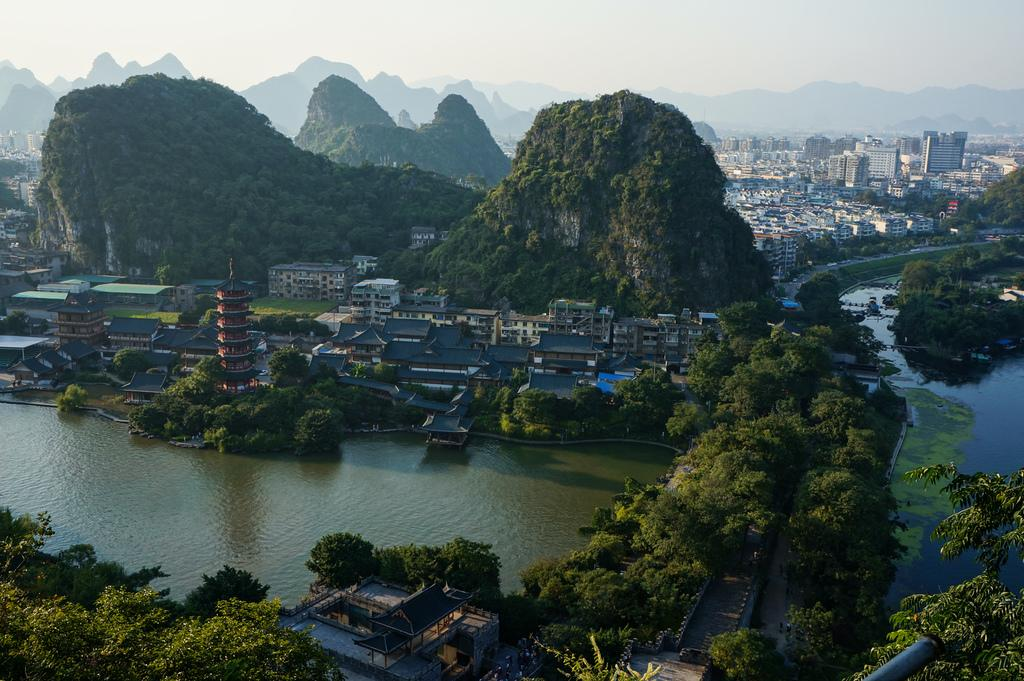What type of structures can be seen in the image? There are buildings in the image. What natural elements are present in the image? There are trees, hills, water, and grass in the image. What man-made feature is visible in the image? There is a road in the image. What part of the natural environment is visible in the image? The sky is visible in the image. Where is the creator of the image located? The creator of the image is not present in the image. What type of sink can be seen in the image? There is no sink present in the image. 